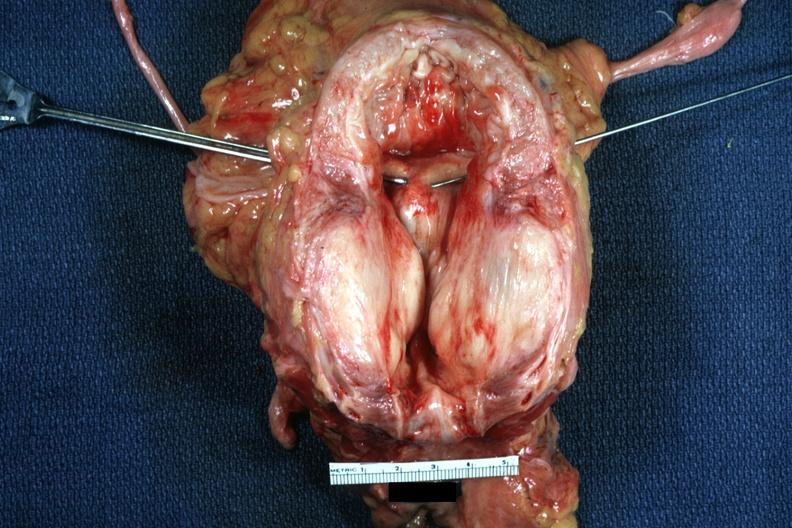s large gland hypertrophied bladder?
Answer the question using a single word or phrase. Yes 